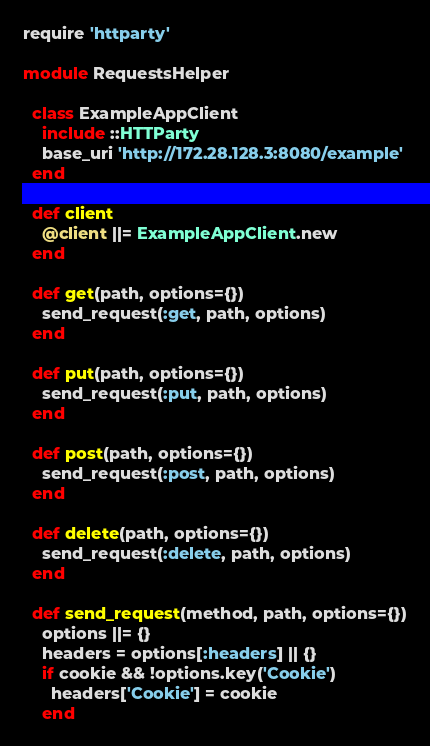Convert code to text. <code><loc_0><loc_0><loc_500><loc_500><_Ruby_>require 'httparty'

module RequestsHelper

  class ExampleAppClient
    include ::HTTParty
    base_uri 'http://172.28.128.3:8080/example'
  end

  def client
    @client ||= ExampleAppClient.new
  end

  def get(path, options={})
    send_request(:get, path, options)
  end

  def put(path, options={})
    send_request(:put, path, options)
  end

  def post(path, options={})
    send_request(:post, path, options)
  end

  def delete(path, options={})
    send_request(:delete, path, options)
  end

  def send_request(method, path, options={})
    options ||= {}
    headers = options[:headers] || {}
    if cookie && !options.key('Cookie')
      headers['Cookie'] = cookie
    end</code> 